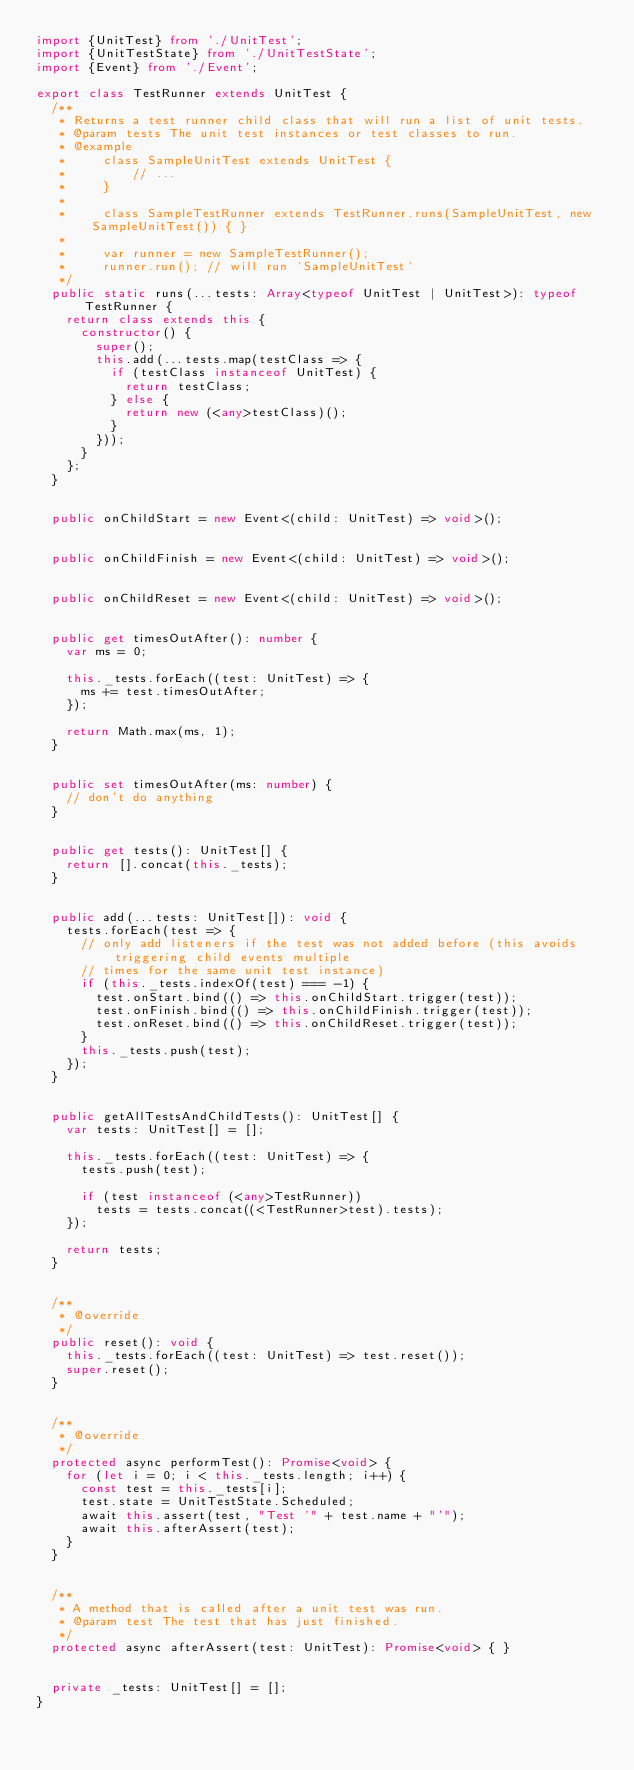<code> <loc_0><loc_0><loc_500><loc_500><_TypeScript_>import {UnitTest} from './UnitTest';
import {UnitTestState} from './UnitTestState';
import {Event} from './Event';

export class TestRunner extends UnitTest {
	/**
	 * Returns a test runner child class that will run a list of unit tests.
	 * @param tests The unit test instances or test classes to run.
	 * @example
	 *     class SampleUnitTest extends UnitTest {
	 *         // ...
	 *     }
	 * 
	 *     class SampleTestRunner extends TestRunner.runs(SampleUnitTest, new SampleUnitTest()) { }
	 * 
	 *     var runner = new SampleTestRunner();
	 *     runner.run(); // will run `SampleUnitTest`
	 */
	public static runs(...tests: Array<typeof UnitTest | UnitTest>): typeof TestRunner {
		return class extends this {
			constructor() {
				super();
				this.add(...tests.map(testClass => {
					if (testClass instanceof UnitTest) {
						return testClass;
					} else {
						return new (<any>testClass)();
					}
				}));
			}
		};
	}
	
	
	public onChildStart = new Event<(child: UnitTest) => void>();
	
	
	public onChildFinish = new Event<(child: UnitTest) => void>();
	
	
	public onChildReset = new Event<(child: UnitTest) => void>();
	
	
	public get timesOutAfter(): number {
		var ms = 0;

		this._tests.forEach((test: UnitTest) => {
			ms += test.timesOutAfter;
		});

		return Math.max(ms, 1);
	}


	public set timesOutAfter(ms: number) {
		// don't do anything
	}


	public get tests(): UnitTest[] {
		return [].concat(this._tests);
	}


	public add(...tests: UnitTest[]): void {
		tests.forEach(test => {
			// only add listeners if the test was not added before (this avoids triggering child events multiple
			// times for the same unit test instance)
			if (this._tests.indexOf(test) === -1) {
				test.onStart.bind(() => this.onChildStart.trigger(test));
				test.onFinish.bind(() => this.onChildFinish.trigger(test));
				test.onReset.bind(() => this.onChildReset.trigger(test));
			}
			this._tests.push(test);
		});
	}


	public getAllTestsAndChildTests(): UnitTest[] {
		var tests: UnitTest[] = [];

		this._tests.forEach((test: UnitTest) => {
			tests.push(test);

			if (test instanceof (<any>TestRunner))
				tests = tests.concat((<TestRunner>test).tests);
		});

		return tests;
	}
	
	
	/**
	 * @override
	 */
	public reset(): void {
		this._tests.forEach((test: UnitTest) => test.reset());
		super.reset();
	}
	

	/**
	 * @override
	 */
	protected async performTest(): Promise<void> {
		for (let i = 0; i < this._tests.length; i++) {
			const test = this._tests[i];
			test.state = UnitTestState.Scheduled;
			await this.assert(test, "Test '" + test.name + "'");
			await this.afterAssert(test);
		}
	}
	
	
	/**
	 * A method that is called after a unit test was run.
	 * @param test The test that has just finished.
	 */
	protected async afterAssert(test: UnitTest): Promise<void> { }


	private _tests: UnitTest[] = [];
}
</code> 